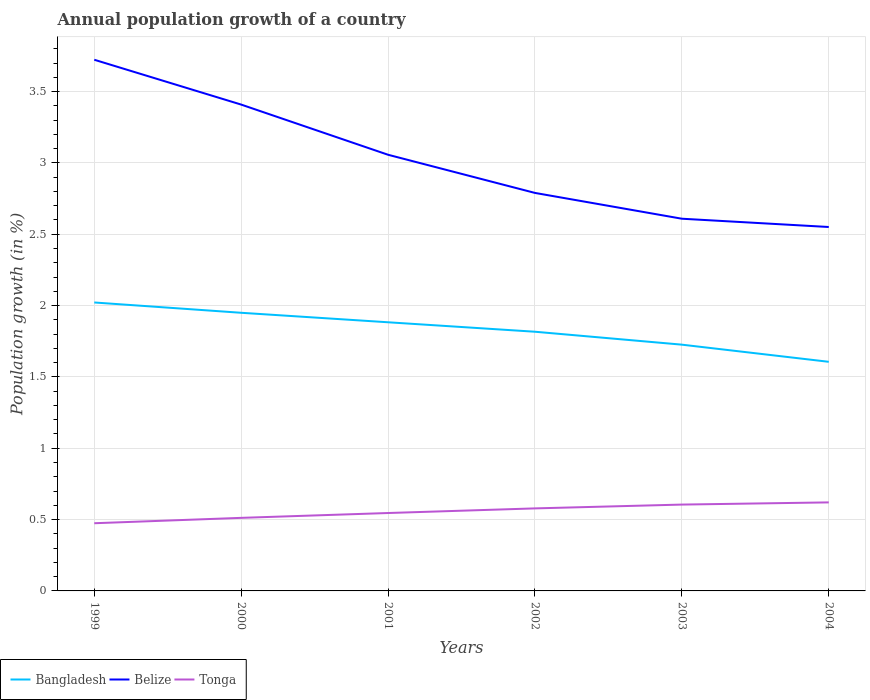Does the line corresponding to Bangladesh intersect with the line corresponding to Tonga?
Your response must be concise. No. Is the number of lines equal to the number of legend labels?
Your answer should be very brief. Yes. Across all years, what is the maximum annual population growth in Belize?
Ensure brevity in your answer.  2.55. In which year was the annual population growth in Bangladesh maximum?
Your response must be concise. 2004. What is the total annual population growth in Belize in the graph?
Provide a succinct answer. 0.93. What is the difference between the highest and the second highest annual population growth in Belize?
Make the answer very short. 1.17. Is the annual population growth in Belize strictly greater than the annual population growth in Bangladesh over the years?
Your answer should be compact. No. How many lines are there?
Ensure brevity in your answer.  3. Does the graph contain any zero values?
Offer a terse response. No. What is the title of the graph?
Offer a terse response. Annual population growth of a country. Does "Austria" appear as one of the legend labels in the graph?
Give a very brief answer. No. What is the label or title of the Y-axis?
Make the answer very short. Population growth (in %). What is the Population growth (in %) of Bangladesh in 1999?
Make the answer very short. 2.02. What is the Population growth (in %) of Belize in 1999?
Make the answer very short. 3.72. What is the Population growth (in %) in Tonga in 1999?
Keep it short and to the point. 0.47. What is the Population growth (in %) of Bangladesh in 2000?
Your response must be concise. 1.95. What is the Population growth (in %) in Belize in 2000?
Give a very brief answer. 3.41. What is the Population growth (in %) of Tonga in 2000?
Provide a succinct answer. 0.51. What is the Population growth (in %) in Bangladesh in 2001?
Provide a short and direct response. 1.88. What is the Population growth (in %) of Belize in 2001?
Ensure brevity in your answer.  3.06. What is the Population growth (in %) in Tonga in 2001?
Provide a short and direct response. 0.55. What is the Population growth (in %) in Bangladesh in 2002?
Your response must be concise. 1.82. What is the Population growth (in %) in Belize in 2002?
Your answer should be compact. 2.79. What is the Population growth (in %) in Tonga in 2002?
Offer a very short reply. 0.58. What is the Population growth (in %) of Bangladesh in 2003?
Ensure brevity in your answer.  1.73. What is the Population growth (in %) in Belize in 2003?
Make the answer very short. 2.61. What is the Population growth (in %) of Tonga in 2003?
Provide a succinct answer. 0.61. What is the Population growth (in %) in Bangladesh in 2004?
Your response must be concise. 1.61. What is the Population growth (in %) of Belize in 2004?
Your answer should be very brief. 2.55. What is the Population growth (in %) in Tonga in 2004?
Give a very brief answer. 0.62. Across all years, what is the maximum Population growth (in %) in Bangladesh?
Offer a very short reply. 2.02. Across all years, what is the maximum Population growth (in %) of Belize?
Your answer should be very brief. 3.72. Across all years, what is the maximum Population growth (in %) in Tonga?
Your answer should be very brief. 0.62. Across all years, what is the minimum Population growth (in %) of Bangladesh?
Your response must be concise. 1.61. Across all years, what is the minimum Population growth (in %) in Belize?
Offer a terse response. 2.55. Across all years, what is the minimum Population growth (in %) of Tonga?
Your response must be concise. 0.47. What is the total Population growth (in %) in Bangladesh in the graph?
Provide a succinct answer. 11. What is the total Population growth (in %) in Belize in the graph?
Offer a very short reply. 18.14. What is the total Population growth (in %) in Tonga in the graph?
Your answer should be compact. 3.34. What is the difference between the Population growth (in %) of Bangladesh in 1999 and that in 2000?
Your response must be concise. 0.07. What is the difference between the Population growth (in %) of Belize in 1999 and that in 2000?
Ensure brevity in your answer.  0.31. What is the difference between the Population growth (in %) of Tonga in 1999 and that in 2000?
Give a very brief answer. -0.04. What is the difference between the Population growth (in %) of Bangladesh in 1999 and that in 2001?
Your answer should be compact. 0.14. What is the difference between the Population growth (in %) of Belize in 1999 and that in 2001?
Your response must be concise. 0.67. What is the difference between the Population growth (in %) in Tonga in 1999 and that in 2001?
Your answer should be very brief. -0.07. What is the difference between the Population growth (in %) of Bangladesh in 1999 and that in 2002?
Offer a terse response. 0.21. What is the difference between the Population growth (in %) of Belize in 1999 and that in 2002?
Provide a succinct answer. 0.93. What is the difference between the Population growth (in %) in Tonga in 1999 and that in 2002?
Provide a succinct answer. -0.1. What is the difference between the Population growth (in %) of Bangladesh in 1999 and that in 2003?
Offer a very short reply. 0.3. What is the difference between the Population growth (in %) of Belize in 1999 and that in 2003?
Offer a very short reply. 1.11. What is the difference between the Population growth (in %) in Tonga in 1999 and that in 2003?
Your response must be concise. -0.13. What is the difference between the Population growth (in %) of Bangladesh in 1999 and that in 2004?
Your answer should be very brief. 0.42. What is the difference between the Population growth (in %) of Belize in 1999 and that in 2004?
Provide a short and direct response. 1.17. What is the difference between the Population growth (in %) in Tonga in 1999 and that in 2004?
Your answer should be compact. -0.15. What is the difference between the Population growth (in %) of Bangladesh in 2000 and that in 2001?
Your answer should be compact. 0.07. What is the difference between the Population growth (in %) of Belize in 2000 and that in 2001?
Provide a succinct answer. 0.35. What is the difference between the Population growth (in %) of Tonga in 2000 and that in 2001?
Ensure brevity in your answer.  -0.03. What is the difference between the Population growth (in %) in Bangladesh in 2000 and that in 2002?
Your answer should be compact. 0.13. What is the difference between the Population growth (in %) of Belize in 2000 and that in 2002?
Your response must be concise. 0.62. What is the difference between the Population growth (in %) in Tonga in 2000 and that in 2002?
Make the answer very short. -0.07. What is the difference between the Population growth (in %) in Bangladesh in 2000 and that in 2003?
Your answer should be very brief. 0.22. What is the difference between the Population growth (in %) in Tonga in 2000 and that in 2003?
Provide a short and direct response. -0.09. What is the difference between the Population growth (in %) of Bangladesh in 2000 and that in 2004?
Provide a succinct answer. 0.34. What is the difference between the Population growth (in %) of Belize in 2000 and that in 2004?
Keep it short and to the point. 0.86. What is the difference between the Population growth (in %) of Tonga in 2000 and that in 2004?
Provide a succinct answer. -0.11. What is the difference between the Population growth (in %) in Bangladesh in 2001 and that in 2002?
Your answer should be very brief. 0.07. What is the difference between the Population growth (in %) in Belize in 2001 and that in 2002?
Your answer should be compact. 0.27. What is the difference between the Population growth (in %) of Tonga in 2001 and that in 2002?
Your response must be concise. -0.03. What is the difference between the Population growth (in %) of Bangladesh in 2001 and that in 2003?
Make the answer very short. 0.16. What is the difference between the Population growth (in %) in Belize in 2001 and that in 2003?
Your response must be concise. 0.45. What is the difference between the Population growth (in %) in Tonga in 2001 and that in 2003?
Your answer should be very brief. -0.06. What is the difference between the Population growth (in %) of Bangladesh in 2001 and that in 2004?
Provide a short and direct response. 0.28. What is the difference between the Population growth (in %) of Belize in 2001 and that in 2004?
Your response must be concise. 0.51. What is the difference between the Population growth (in %) of Tonga in 2001 and that in 2004?
Your answer should be very brief. -0.07. What is the difference between the Population growth (in %) in Bangladesh in 2002 and that in 2003?
Keep it short and to the point. 0.09. What is the difference between the Population growth (in %) in Belize in 2002 and that in 2003?
Offer a terse response. 0.18. What is the difference between the Population growth (in %) in Tonga in 2002 and that in 2003?
Give a very brief answer. -0.03. What is the difference between the Population growth (in %) of Bangladesh in 2002 and that in 2004?
Your response must be concise. 0.21. What is the difference between the Population growth (in %) in Belize in 2002 and that in 2004?
Provide a short and direct response. 0.24. What is the difference between the Population growth (in %) of Tonga in 2002 and that in 2004?
Your answer should be very brief. -0.04. What is the difference between the Population growth (in %) of Bangladesh in 2003 and that in 2004?
Make the answer very short. 0.12. What is the difference between the Population growth (in %) of Belize in 2003 and that in 2004?
Your response must be concise. 0.06. What is the difference between the Population growth (in %) in Tonga in 2003 and that in 2004?
Offer a very short reply. -0.02. What is the difference between the Population growth (in %) in Bangladesh in 1999 and the Population growth (in %) in Belize in 2000?
Your answer should be compact. -1.39. What is the difference between the Population growth (in %) of Bangladesh in 1999 and the Population growth (in %) of Tonga in 2000?
Give a very brief answer. 1.51. What is the difference between the Population growth (in %) of Belize in 1999 and the Population growth (in %) of Tonga in 2000?
Make the answer very short. 3.21. What is the difference between the Population growth (in %) of Bangladesh in 1999 and the Population growth (in %) of Belize in 2001?
Keep it short and to the point. -1.04. What is the difference between the Population growth (in %) of Bangladesh in 1999 and the Population growth (in %) of Tonga in 2001?
Provide a succinct answer. 1.48. What is the difference between the Population growth (in %) in Belize in 1999 and the Population growth (in %) in Tonga in 2001?
Offer a terse response. 3.18. What is the difference between the Population growth (in %) of Bangladesh in 1999 and the Population growth (in %) of Belize in 2002?
Your answer should be very brief. -0.77. What is the difference between the Population growth (in %) in Bangladesh in 1999 and the Population growth (in %) in Tonga in 2002?
Give a very brief answer. 1.44. What is the difference between the Population growth (in %) in Belize in 1999 and the Population growth (in %) in Tonga in 2002?
Your answer should be very brief. 3.14. What is the difference between the Population growth (in %) in Bangladesh in 1999 and the Population growth (in %) in Belize in 2003?
Your answer should be compact. -0.59. What is the difference between the Population growth (in %) of Bangladesh in 1999 and the Population growth (in %) of Tonga in 2003?
Ensure brevity in your answer.  1.42. What is the difference between the Population growth (in %) of Belize in 1999 and the Population growth (in %) of Tonga in 2003?
Your response must be concise. 3.12. What is the difference between the Population growth (in %) in Bangladesh in 1999 and the Population growth (in %) in Belize in 2004?
Make the answer very short. -0.53. What is the difference between the Population growth (in %) of Bangladesh in 1999 and the Population growth (in %) of Tonga in 2004?
Make the answer very short. 1.4. What is the difference between the Population growth (in %) of Belize in 1999 and the Population growth (in %) of Tonga in 2004?
Provide a succinct answer. 3.1. What is the difference between the Population growth (in %) of Bangladesh in 2000 and the Population growth (in %) of Belize in 2001?
Provide a short and direct response. -1.11. What is the difference between the Population growth (in %) of Bangladesh in 2000 and the Population growth (in %) of Tonga in 2001?
Your answer should be compact. 1.4. What is the difference between the Population growth (in %) of Belize in 2000 and the Population growth (in %) of Tonga in 2001?
Ensure brevity in your answer.  2.86. What is the difference between the Population growth (in %) in Bangladesh in 2000 and the Population growth (in %) in Belize in 2002?
Provide a succinct answer. -0.84. What is the difference between the Population growth (in %) in Bangladesh in 2000 and the Population growth (in %) in Tonga in 2002?
Your answer should be compact. 1.37. What is the difference between the Population growth (in %) in Belize in 2000 and the Population growth (in %) in Tonga in 2002?
Give a very brief answer. 2.83. What is the difference between the Population growth (in %) of Bangladesh in 2000 and the Population growth (in %) of Belize in 2003?
Your answer should be very brief. -0.66. What is the difference between the Population growth (in %) in Bangladesh in 2000 and the Population growth (in %) in Tonga in 2003?
Your answer should be compact. 1.34. What is the difference between the Population growth (in %) of Belize in 2000 and the Population growth (in %) of Tonga in 2003?
Give a very brief answer. 2.8. What is the difference between the Population growth (in %) in Bangladesh in 2000 and the Population growth (in %) in Belize in 2004?
Ensure brevity in your answer.  -0.6. What is the difference between the Population growth (in %) of Bangladesh in 2000 and the Population growth (in %) of Tonga in 2004?
Provide a succinct answer. 1.33. What is the difference between the Population growth (in %) in Belize in 2000 and the Population growth (in %) in Tonga in 2004?
Offer a very short reply. 2.79. What is the difference between the Population growth (in %) in Bangladesh in 2001 and the Population growth (in %) in Belize in 2002?
Give a very brief answer. -0.91. What is the difference between the Population growth (in %) in Bangladesh in 2001 and the Population growth (in %) in Tonga in 2002?
Give a very brief answer. 1.3. What is the difference between the Population growth (in %) of Belize in 2001 and the Population growth (in %) of Tonga in 2002?
Offer a terse response. 2.48. What is the difference between the Population growth (in %) in Bangladesh in 2001 and the Population growth (in %) in Belize in 2003?
Offer a very short reply. -0.73. What is the difference between the Population growth (in %) in Bangladesh in 2001 and the Population growth (in %) in Tonga in 2003?
Keep it short and to the point. 1.28. What is the difference between the Population growth (in %) of Belize in 2001 and the Population growth (in %) of Tonga in 2003?
Your answer should be very brief. 2.45. What is the difference between the Population growth (in %) of Bangladesh in 2001 and the Population growth (in %) of Belize in 2004?
Your response must be concise. -0.67. What is the difference between the Population growth (in %) in Bangladesh in 2001 and the Population growth (in %) in Tonga in 2004?
Your answer should be compact. 1.26. What is the difference between the Population growth (in %) in Belize in 2001 and the Population growth (in %) in Tonga in 2004?
Offer a very short reply. 2.44. What is the difference between the Population growth (in %) in Bangladesh in 2002 and the Population growth (in %) in Belize in 2003?
Keep it short and to the point. -0.79. What is the difference between the Population growth (in %) of Bangladesh in 2002 and the Population growth (in %) of Tonga in 2003?
Give a very brief answer. 1.21. What is the difference between the Population growth (in %) in Belize in 2002 and the Population growth (in %) in Tonga in 2003?
Offer a very short reply. 2.18. What is the difference between the Population growth (in %) of Bangladesh in 2002 and the Population growth (in %) of Belize in 2004?
Provide a succinct answer. -0.73. What is the difference between the Population growth (in %) in Bangladesh in 2002 and the Population growth (in %) in Tonga in 2004?
Give a very brief answer. 1.2. What is the difference between the Population growth (in %) of Belize in 2002 and the Population growth (in %) of Tonga in 2004?
Your answer should be very brief. 2.17. What is the difference between the Population growth (in %) in Bangladesh in 2003 and the Population growth (in %) in Belize in 2004?
Offer a terse response. -0.82. What is the difference between the Population growth (in %) of Bangladesh in 2003 and the Population growth (in %) of Tonga in 2004?
Your answer should be very brief. 1.11. What is the difference between the Population growth (in %) in Belize in 2003 and the Population growth (in %) in Tonga in 2004?
Give a very brief answer. 1.99. What is the average Population growth (in %) of Bangladesh per year?
Provide a short and direct response. 1.83. What is the average Population growth (in %) in Belize per year?
Ensure brevity in your answer.  3.02. What is the average Population growth (in %) of Tonga per year?
Provide a succinct answer. 0.56. In the year 1999, what is the difference between the Population growth (in %) of Bangladesh and Population growth (in %) of Belize?
Make the answer very short. -1.7. In the year 1999, what is the difference between the Population growth (in %) of Bangladesh and Population growth (in %) of Tonga?
Offer a very short reply. 1.55. In the year 1999, what is the difference between the Population growth (in %) in Belize and Population growth (in %) in Tonga?
Offer a very short reply. 3.25. In the year 2000, what is the difference between the Population growth (in %) in Bangladesh and Population growth (in %) in Belize?
Keep it short and to the point. -1.46. In the year 2000, what is the difference between the Population growth (in %) of Bangladesh and Population growth (in %) of Tonga?
Provide a succinct answer. 1.44. In the year 2000, what is the difference between the Population growth (in %) in Belize and Population growth (in %) in Tonga?
Offer a very short reply. 2.9. In the year 2001, what is the difference between the Population growth (in %) in Bangladesh and Population growth (in %) in Belize?
Ensure brevity in your answer.  -1.17. In the year 2001, what is the difference between the Population growth (in %) of Bangladesh and Population growth (in %) of Tonga?
Your response must be concise. 1.34. In the year 2001, what is the difference between the Population growth (in %) in Belize and Population growth (in %) in Tonga?
Provide a short and direct response. 2.51. In the year 2002, what is the difference between the Population growth (in %) of Bangladesh and Population growth (in %) of Belize?
Ensure brevity in your answer.  -0.97. In the year 2002, what is the difference between the Population growth (in %) of Bangladesh and Population growth (in %) of Tonga?
Make the answer very short. 1.24. In the year 2002, what is the difference between the Population growth (in %) of Belize and Population growth (in %) of Tonga?
Provide a succinct answer. 2.21. In the year 2003, what is the difference between the Population growth (in %) of Bangladesh and Population growth (in %) of Belize?
Provide a succinct answer. -0.88. In the year 2003, what is the difference between the Population growth (in %) in Bangladesh and Population growth (in %) in Tonga?
Provide a succinct answer. 1.12. In the year 2003, what is the difference between the Population growth (in %) in Belize and Population growth (in %) in Tonga?
Ensure brevity in your answer.  2. In the year 2004, what is the difference between the Population growth (in %) of Bangladesh and Population growth (in %) of Belize?
Offer a very short reply. -0.94. In the year 2004, what is the difference between the Population growth (in %) in Belize and Population growth (in %) in Tonga?
Give a very brief answer. 1.93. What is the ratio of the Population growth (in %) in Bangladesh in 1999 to that in 2000?
Offer a terse response. 1.04. What is the ratio of the Population growth (in %) in Belize in 1999 to that in 2000?
Keep it short and to the point. 1.09. What is the ratio of the Population growth (in %) of Tonga in 1999 to that in 2000?
Your answer should be very brief. 0.93. What is the ratio of the Population growth (in %) of Bangladesh in 1999 to that in 2001?
Make the answer very short. 1.07. What is the ratio of the Population growth (in %) of Belize in 1999 to that in 2001?
Make the answer very short. 1.22. What is the ratio of the Population growth (in %) in Tonga in 1999 to that in 2001?
Your answer should be compact. 0.87. What is the ratio of the Population growth (in %) in Bangladesh in 1999 to that in 2002?
Ensure brevity in your answer.  1.11. What is the ratio of the Population growth (in %) in Belize in 1999 to that in 2002?
Give a very brief answer. 1.33. What is the ratio of the Population growth (in %) in Tonga in 1999 to that in 2002?
Offer a terse response. 0.82. What is the ratio of the Population growth (in %) in Bangladesh in 1999 to that in 2003?
Your answer should be compact. 1.17. What is the ratio of the Population growth (in %) of Belize in 1999 to that in 2003?
Your answer should be very brief. 1.43. What is the ratio of the Population growth (in %) of Tonga in 1999 to that in 2003?
Your answer should be very brief. 0.78. What is the ratio of the Population growth (in %) of Bangladesh in 1999 to that in 2004?
Ensure brevity in your answer.  1.26. What is the ratio of the Population growth (in %) in Belize in 1999 to that in 2004?
Your answer should be compact. 1.46. What is the ratio of the Population growth (in %) in Tonga in 1999 to that in 2004?
Provide a short and direct response. 0.76. What is the ratio of the Population growth (in %) of Bangladesh in 2000 to that in 2001?
Offer a very short reply. 1.04. What is the ratio of the Population growth (in %) in Belize in 2000 to that in 2001?
Offer a terse response. 1.11. What is the ratio of the Population growth (in %) of Tonga in 2000 to that in 2001?
Your response must be concise. 0.94. What is the ratio of the Population growth (in %) of Bangladesh in 2000 to that in 2002?
Ensure brevity in your answer.  1.07. What is the ratio of the Population growth (in %) in Belize in 2000 to that in 2002?
Keep it short and to the point. 1.22. What is the ratio of the Population growth (in %) in Tonga in 2000 to that in 2002?
Your response must be concise. 0.89. What is the ratio of the Population growth (in %) in Bangladesh in 2000 to that in 2003?
Your answer should be compact. 1.13. What is the ratio of the Population growth (in %) of Belize in 2000 to that in 2003?
Give a very brief answer. 1.31. What is the ratio of the Population growth (in %) in Tonga in 2000 to that in 2003?
Offer a very short reply. 0.85. What is the ratio of the Population growth (in %) of Bangladesh in 2000 to that in 2004?
Your answer should be very brief. 1.21. What is the ratio of the Population growth (in %) of Belize in 2000 to that in 2004?
Ensure brevity in your answer.  1.34. What is the ratio of the Population growth (in %) of Tonga in 2000 to that in 2004?
Make the answer very short. 0.83. What is the ratio of the Population growth (in %) in Bangladesh in 2001 to that in 2002?
Ensure brevity in your answer.  1.04. What is the ratio of the Population growth (in %) in Belize in 2001 to that in 2002?
Give a very brief answer. 1.1. What is the ratio of the Population growth (in %) in Tonga in 2001 to that in 2002?
Your response must be concise. 0.94. What is the ratio of the Population growth (in %) of Belize in 2001 to that in 2003?
Ensure brevity in your answer.  1.17. What is the ratio of the Population growth (in %) of Tonga in 2001 to that in 2003?
Offer a terse response. 0.9. What is the ratio of the Population growth (in %) in Bangladesh in 2001 to that in 2004?
Make the answer very short. 1.17. What is the ratio of the Population growth (in %) of Belize in 2001 to that in 2004?
Provide a short and direct response. 1.2. What is the ratio of the Population growth (in %) in Tonga in 2001 to that in 2004?
Offer a very short reply. 0.88. What is the ratio of the Population growth (in %) in Bangladesh in 2002 to that in 2003?
Your answer should be very brief. 1.05. What is the ratio of the Population growth (in %) of Belize in 2002 to that in 2003?
Your answer should be very brief. 1.07. What is the ratio of the Population growth (in %) in Tonga in 2002 to that in 2003?
Your answer should be very brief. 0.96. What is the ratio of the Population growth (in %) in Bangladesh in 2002 to that in 2004?
Offer a terse response. 1.13. What is the ratio of the Population growth (in %) in Belize in 2002 to that in 2004?
Give a very brief answer. 1.09. What is the ratio of the Population growth (in %) in Tonga in 2002 to that in 2004?
Give a very brief answer. 0.93. What is the ratio of the Population growth (in %) in Bangladesh in 2003 to that in 2004?
Make the answer very short. 1.07. What is the ratio of the Population growth (in %) in Belize in 2003 to that in 2004?
Provide a succinct answer. 1.02. What is the ratio of the Population growth (in %) in Tonga in 2003 to that in 2004?
Provide a succinct answer. 0.98. What is the difference between the highest and the second highest Population growth (in %) of Bangladesh?
Provide a succinct answer. 0.07. What is the difference between the highest and the second highest Population growth (in %) of Belize?
Make the answer very short. 0.31. What is the difference between the highest and the second highest Population growth (in %) of Tonga?
Your answer should be very brief. 0.02. What is the difference between the highest and the lowest Population growth (in %) in Bangladesh?
Offer a very short reply. 0.42. What is the difference between the highest and the lowest Population growth (in %) in Belize?
Offer a terse response. 1.17. What is the difference between the highest and the lowest Population growth (in %) in Tonga?
Keep it short and to the point. 0.15. 